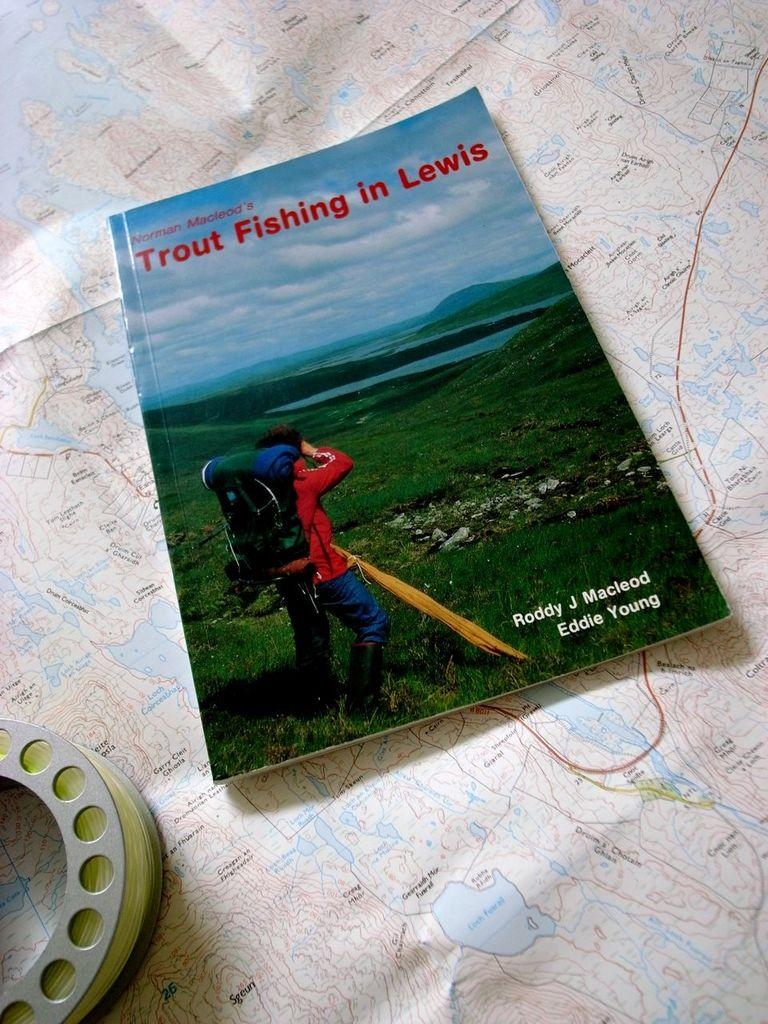Provide a one-sentence caption for the provided image. The book Norman Macleod's Trout Fishing in Lewis is laid on a map next to a fly fishing reel. 